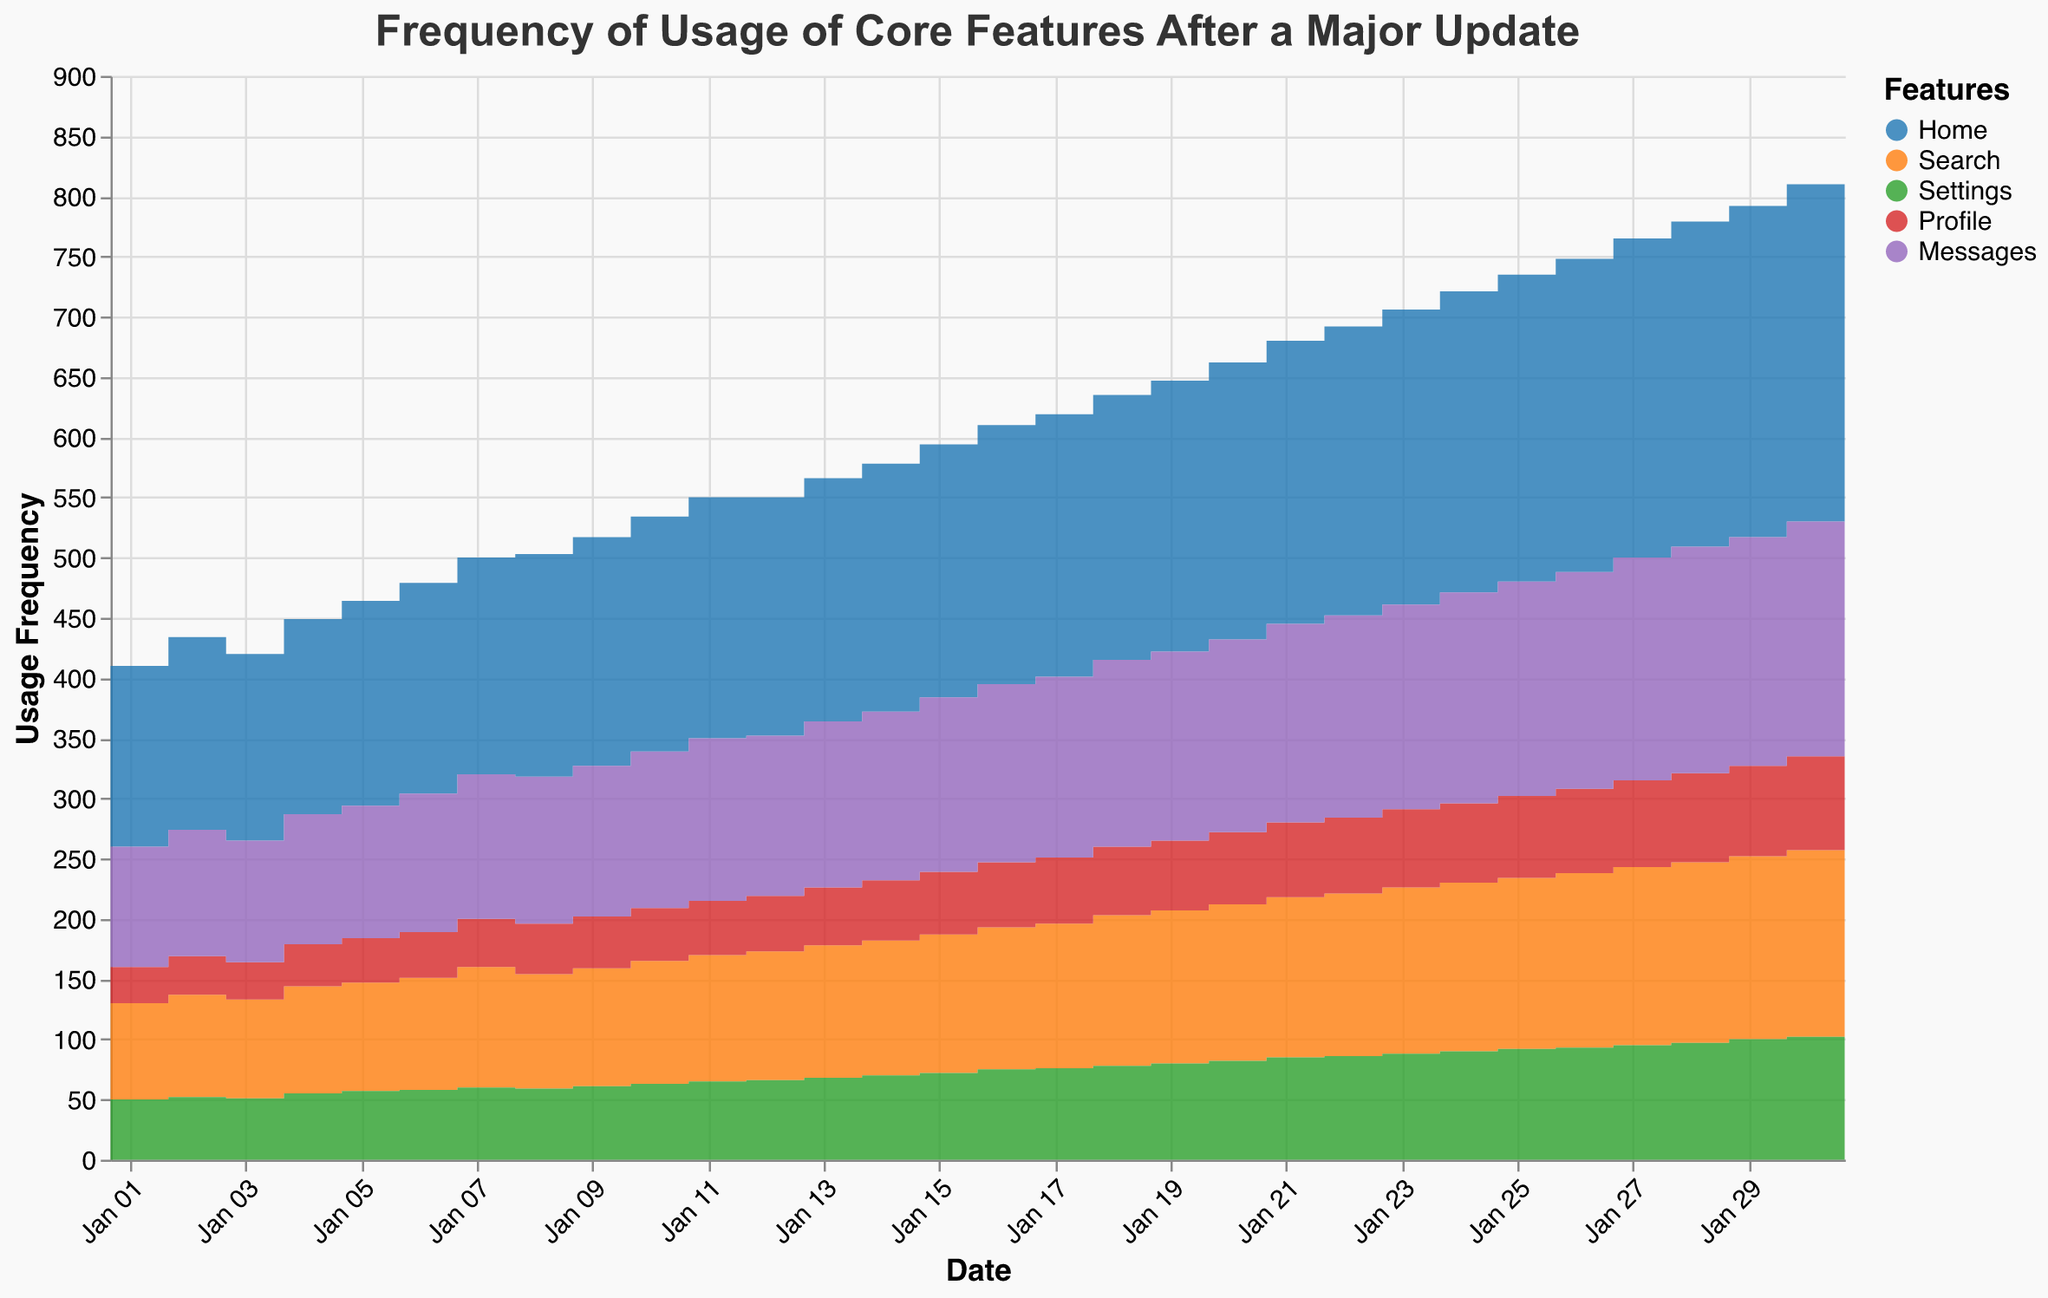what is the title of the figure? The title of the figure is usually found at the top and describes the main content of the chart.
Answer: Frequency of Usage of Core Features After a Major Update how many features are displayed in the chart? The legend typically shows all categories represented in the chart.
Answer: 5 which feature had the highest usage on January 31, 2023? By examining the values along the y-axis for January 31, we see the highest total usage point belongs to the "Home" feature.
Answer: Home which two features showed the most similar usage pattern over the month? By visually comparing the trends of different features over the entire period, "Settings" and "Profile" appear to have very similar usage patterns with fewer peaks and troughs.
Answer: Settings and Profile how did the usage of the 'Messages' feature trend from January 1 to January 31? Observing the trend from January 1 to January 31, "Messages" feature steadily increased without any significant dips.
Answer: Increased steadily on January 20, which feature had the lowest usage frequency? By checking the value for each feature on January 20, the "Profile" feature had the lowest usage frequency.
Answer: Profile what is the difference in usage frequency of "Home" between January 1 and January 31? The value for "Home" on January 1 is 150, and on January 31 it is 285. The difference is 285 - 150 = 135.
Answer: 135 what is the average usage frequency of the 'Search' feature over the first week? Adding the daily usage values for 'Search' from January 1 to January 7, we get (80+85+82+89+90+93+100)=619. Dividing this by 7: 619/7 = ~88.43.
Answer: ~88.43 what can be inferred about user engagement from the trend of "Home" feature usage? The steady increase in the "Home" feature usage suggests growing user engagement with the new update as time progressed.
Answer: Increasing engagement which date had the highest total usage frequency across all features? Summing up the values of all features across each date, January 31 stands out as it has the highest values for individual features: 285 (Home) + 160 (Search) + 105 (Settings) + 80 (Profile) + 200 (Messages) = 830.
Answer: January 31 